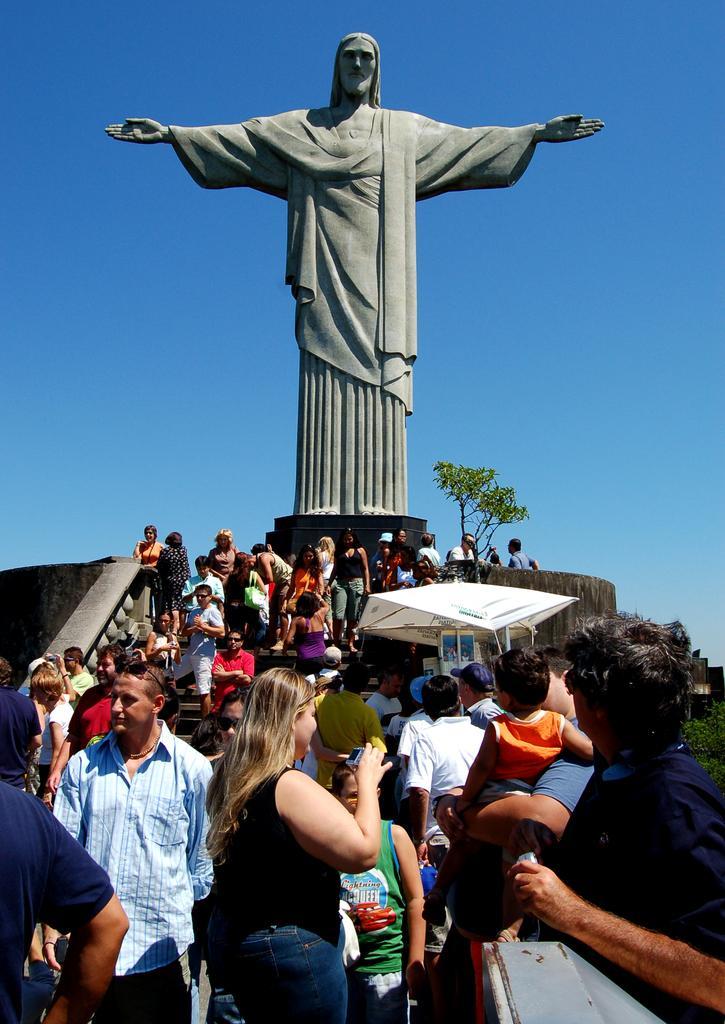How would you summarize this image in a sentence or two? In this picture we can see a statue, tent, tree and a group of people on steps were a woman holding a camera with her hand and in the background we can see the sky. 